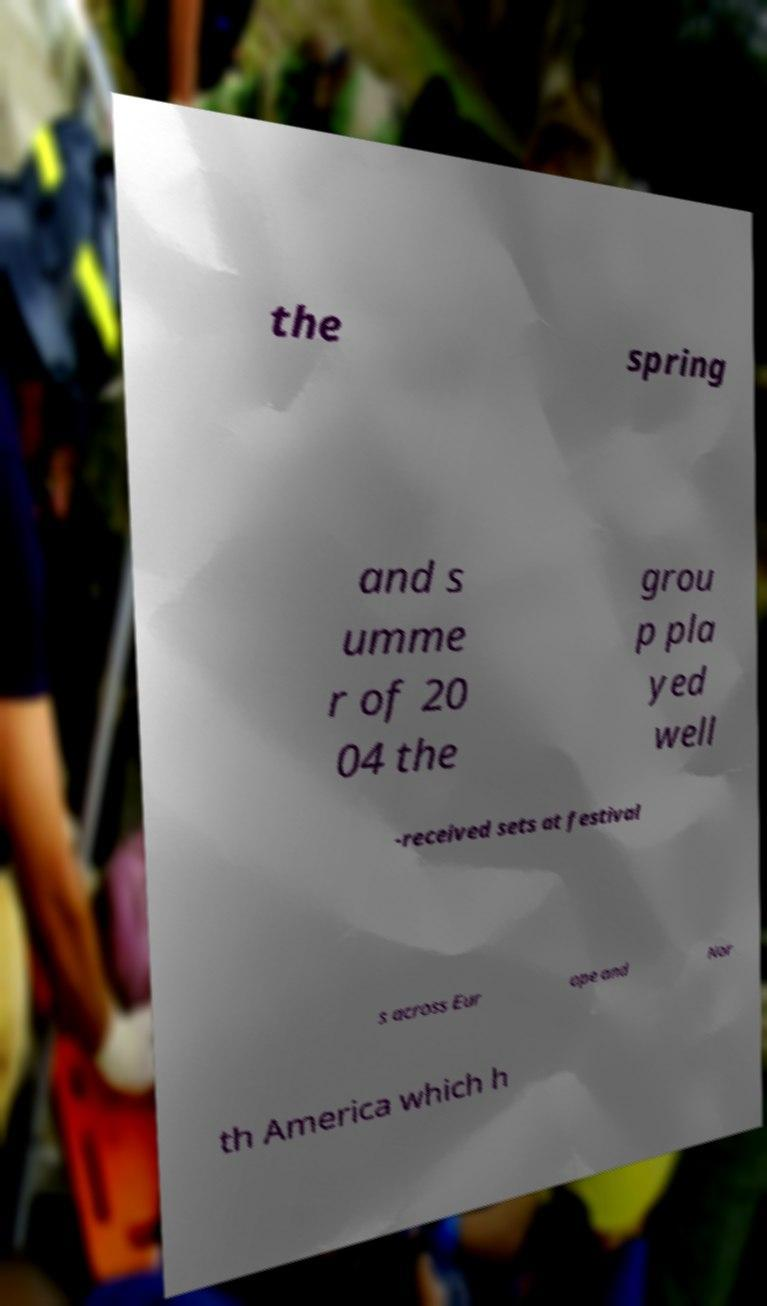I need the written content from this picture converted into text. Can you do that? the spring and s umme r of 20 04 the grou p pla yed well -received sets at festival s across Eur ope and Nor th America which h 